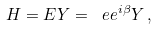<formula> <loc_0><loc_0><loc_500><loc_500>H = E Y = \ e e ^ { i \beta } Y \, ,</formula> 